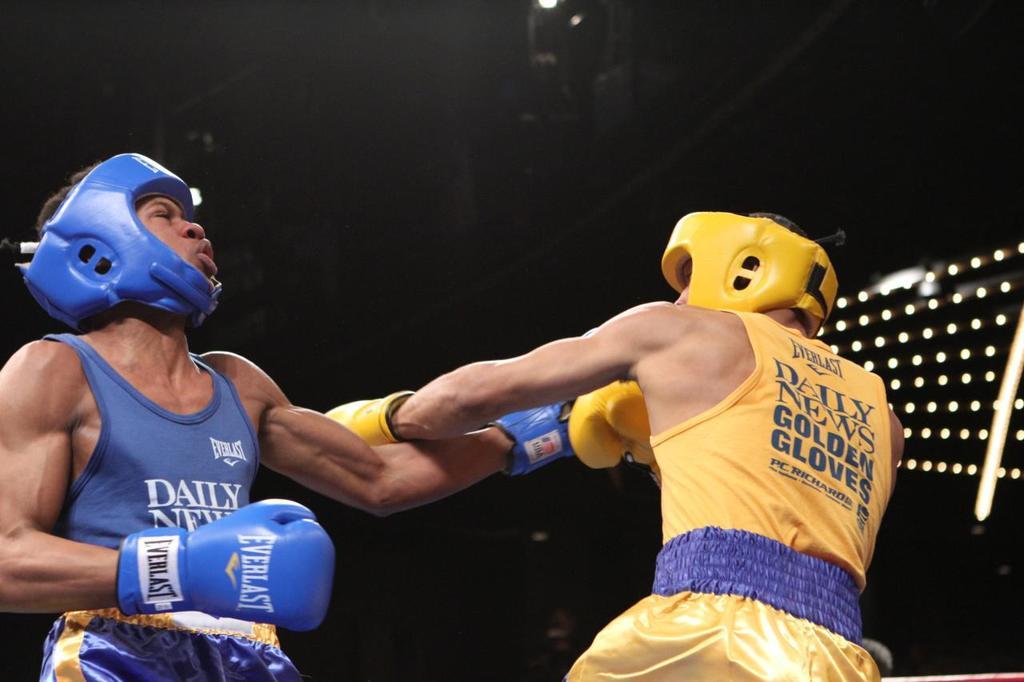What is the writing on the blue boxer's glove?
Your answer should be compact. Everlast. 